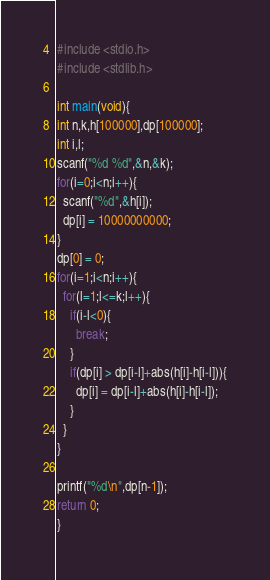<code> <loc_0><loc_0><loc_500><loc_500><_C_>#include <stdio.h>
#include <stdlib.h>

int main(void){
int n,k,h[100000],dp[100000];
int i,l;
scanf("%d %d",&n,&k);
for(i=0;i<n;i++){
  scanf("%d",&h[i]);
  dp[i] = 10000000000;
}
dp[0] = 0;
for(i=1;i<n;i++){
  for(l=1;l<=k;l++){
    if(i-l<0){
      break;
    }
    if(dp[i] > dp[i-l]+abs(h[i]-h[i-l])){
      dp[i] = dp[i-l]+abs(h[i]-h[i-l]);
    }
  }
}

printf("%d\n",dp[n-1]);
return 0;                          
}</code> 